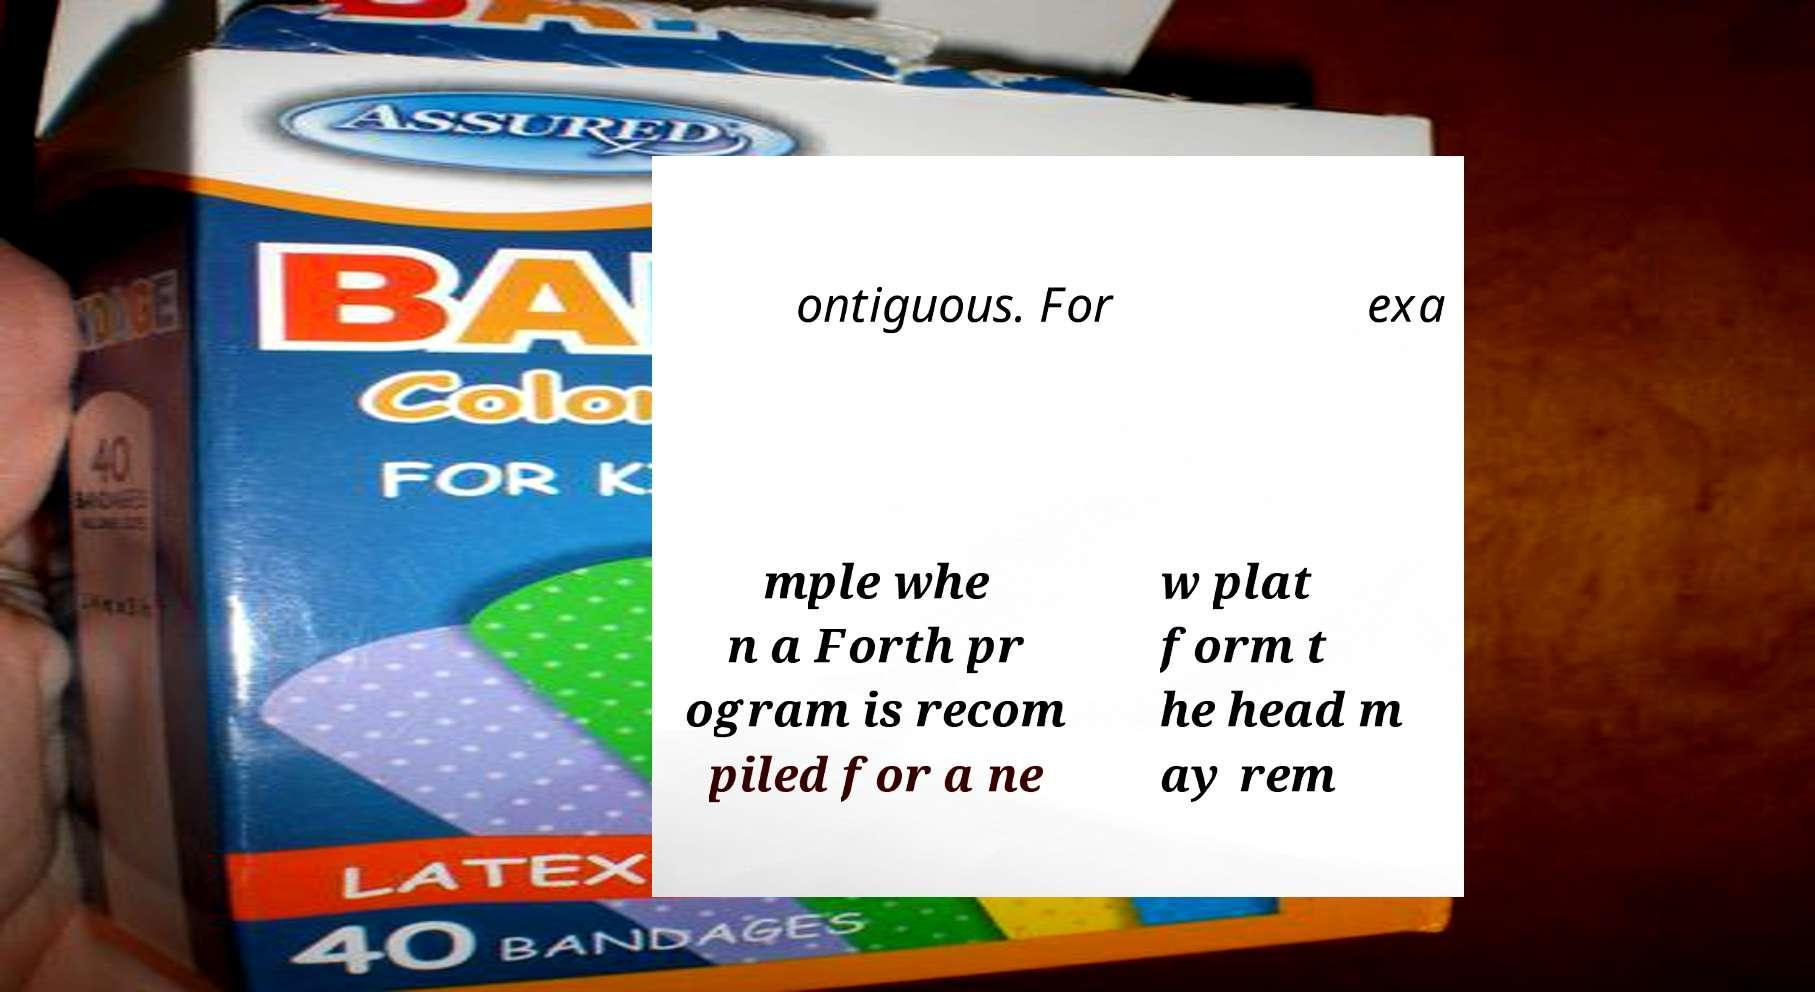There's text embedded in this image that I need extracted. Can you transcribe it verbatim? ontiguous. For exa mple whe n a Forth pr ogram is recom piled for a ne w plat form t he head m ay rem 